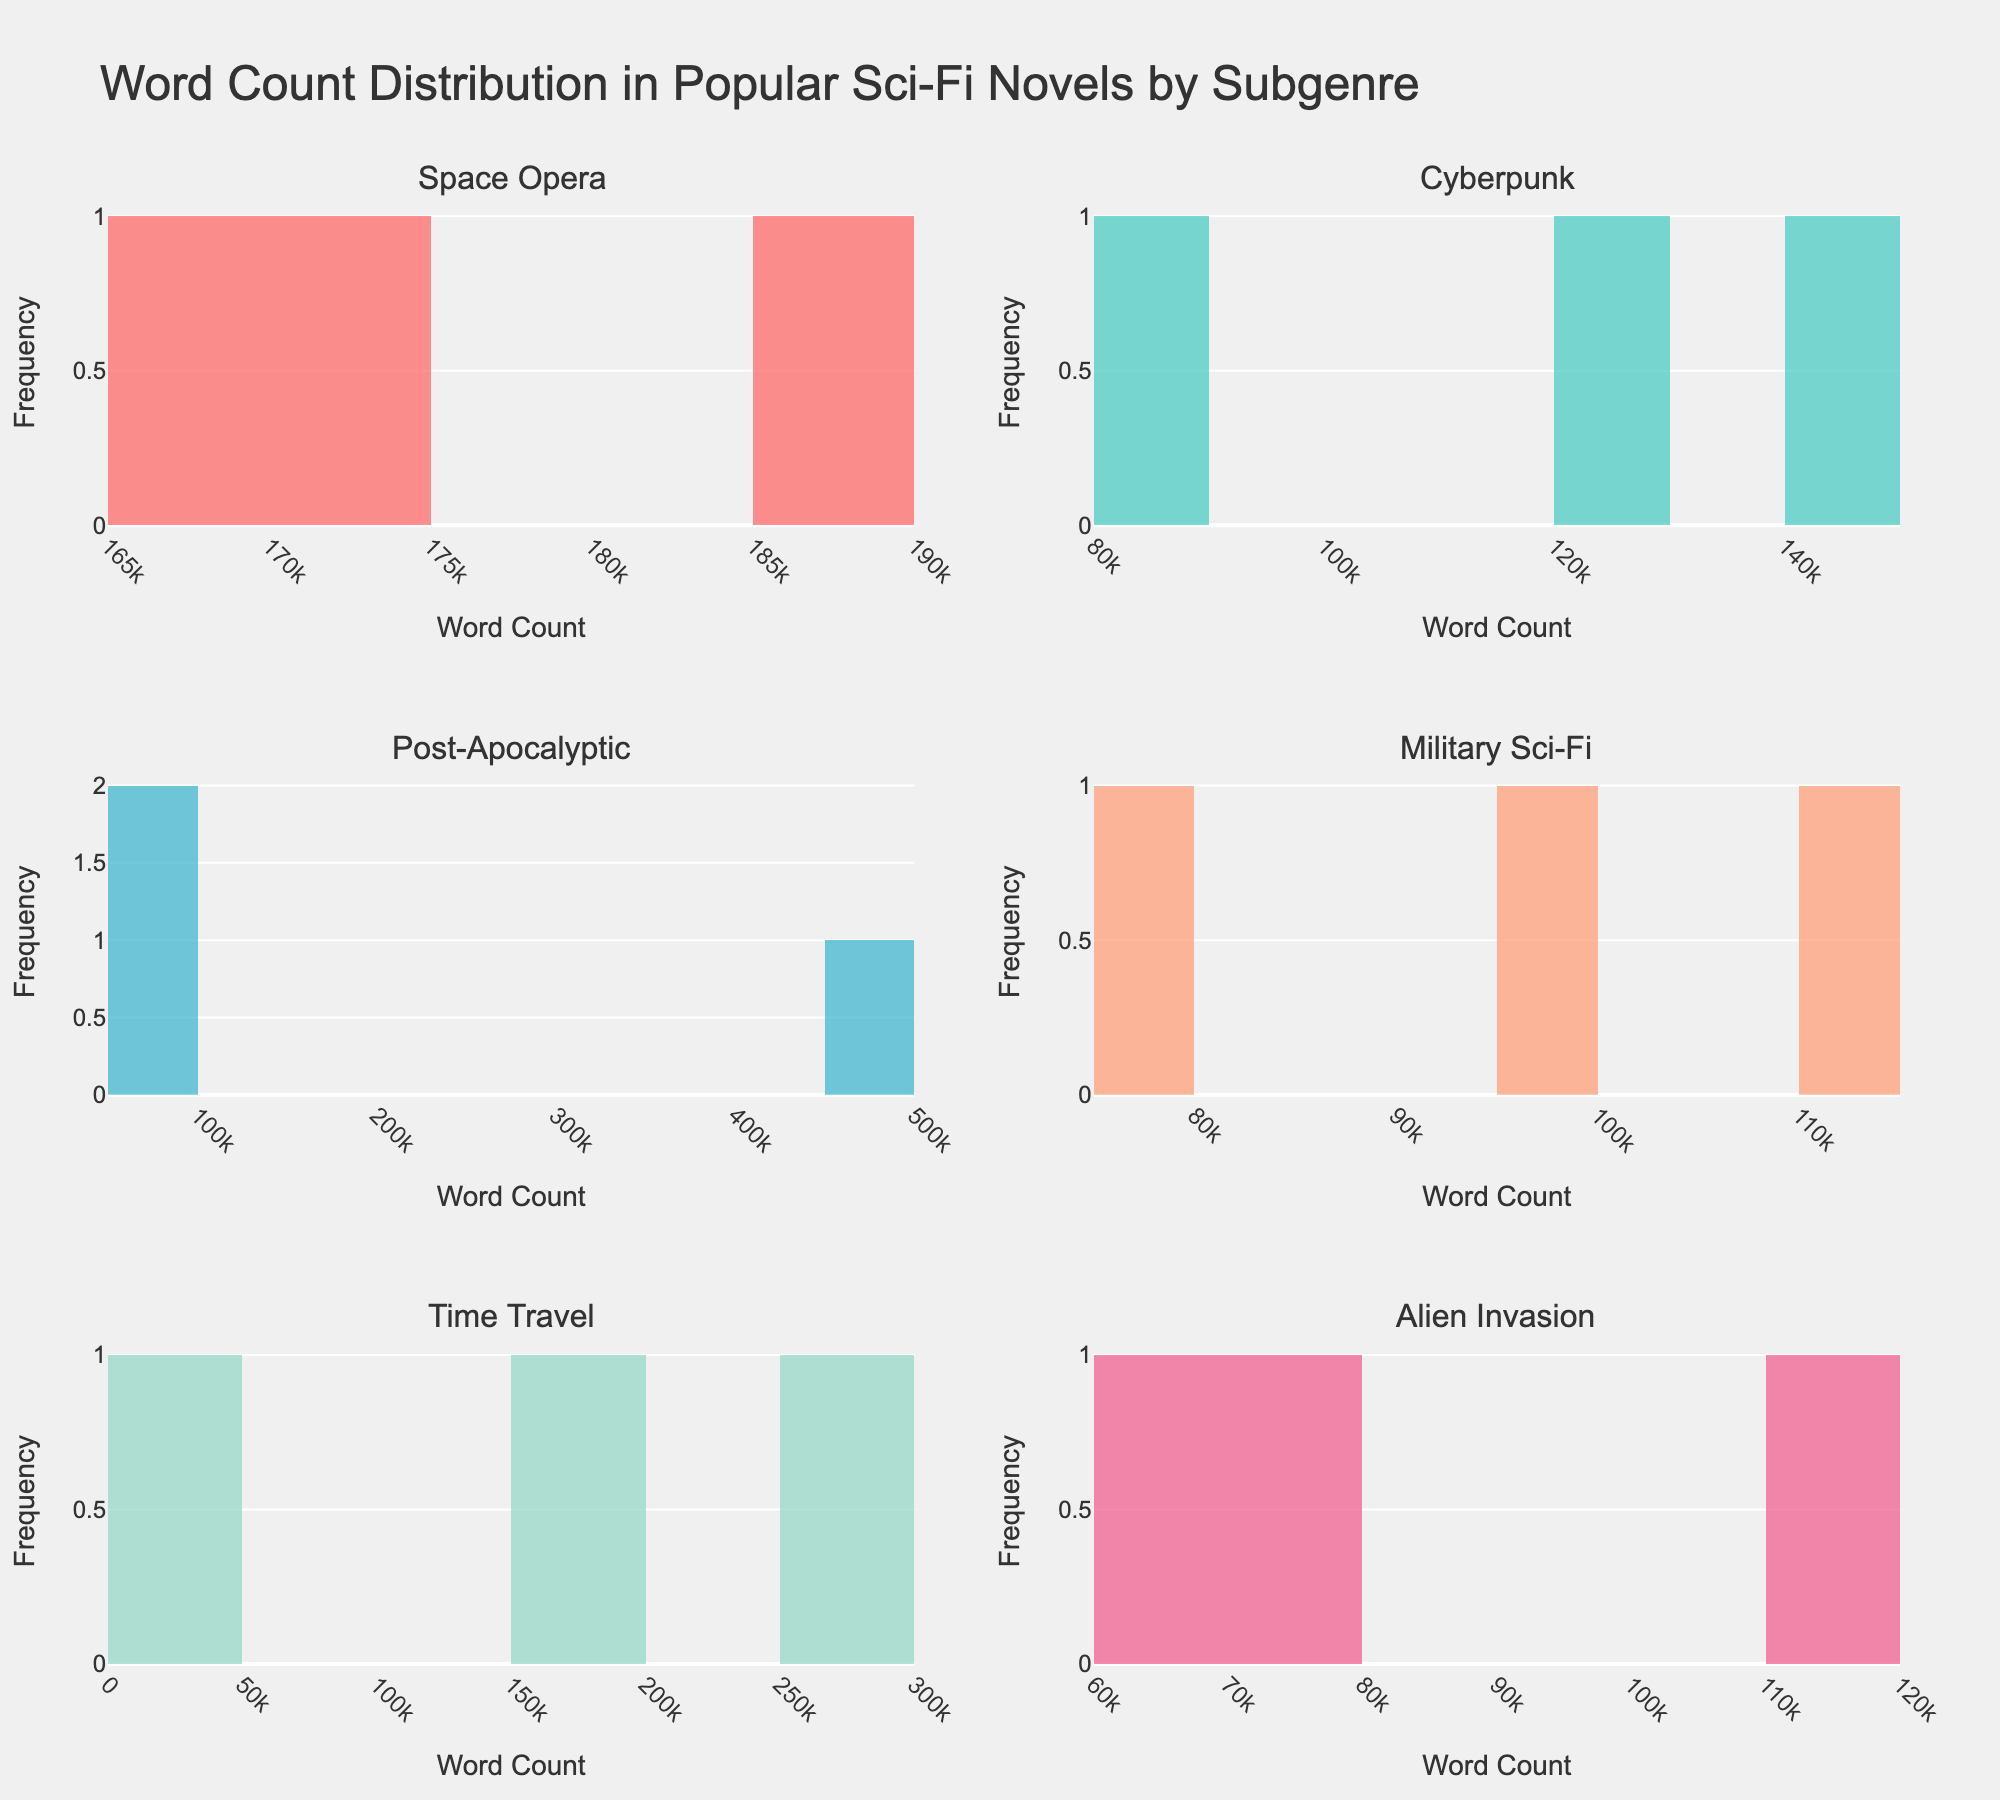How many subgenres are displayed in the plots? The figure contains subplots for each subgenre. By counting the subplot titles, you can determine the number of subgenres represented.
Answer: 6 Which subgenre has the greatest variation in word count? To determine this, you need to compare the spread of the histograms across all subgenres. The one with the widest spread in word count values indicates the greatest variation.
Answer: Post-Apocalyptic What is the most common word count range for Military Sci-Fi novels? Examine the histogram for Military Sci-Fi and identify the bin with the highest frequency. This represents the most common word count range.
Answer: 90,000-110,000 Which subgenre has the shortest word count, and what is the word count? Look at each histogram and identify the shortest word count bin. Then verify the corresponding subgenre.
Answer: Time Travel, 32,000 How does the median word count of Cyberpunk novels compare to that of Space Opera? To find the median, look at the histogram for each subgenre and identify the middle value. You can then compare these two medians.
Answer: Cyberpunk’s median is lower than Space Opera’s What is the frequency of the word count bin 80,000-90,000 for Post-Apocalyptic novels? Locate the bin corresponding to the 80,000-90,000 word count range in the Post-Apocalyptic histogram and observe the frequency indicated by the height of the bar.
Answer: 1 Which subgenre has the highest average word count? The subgenre with the highest average word count can be identified by comparing the central tendency around higher word counts in each histogram.
Answer: Time Travel How many data points are plotted for the Alien Invasion subgenre? Count the number of publications shown in the Alien Invasion histogram to find the total number of data points.
Answer: 3 Is there any overlap in word counts between Cyberpunk and Alien Invasion novels? Compare the ranges of word counts in the histograms for Cyberpunk and Alien Invasion to determine if there's any overlapping area.
Answer: Yes Which subgenre exhibits the least frequency variation in word counts? Look at the histograms for uniformity in bar heights which would indicate less variation in word counts.
Answer: Military Sci-Fi 